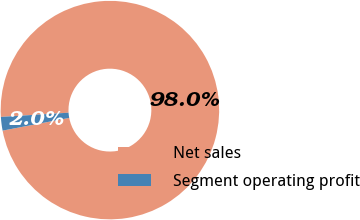Convert chart to OTSL. <chart><loc_0><loc_0><loc_500><loc_500><pie_chart><fcel>Net sales<fcel>Segment operating profit<nl><fcel>97.99%<fcel>2.01%<nl></chart> 